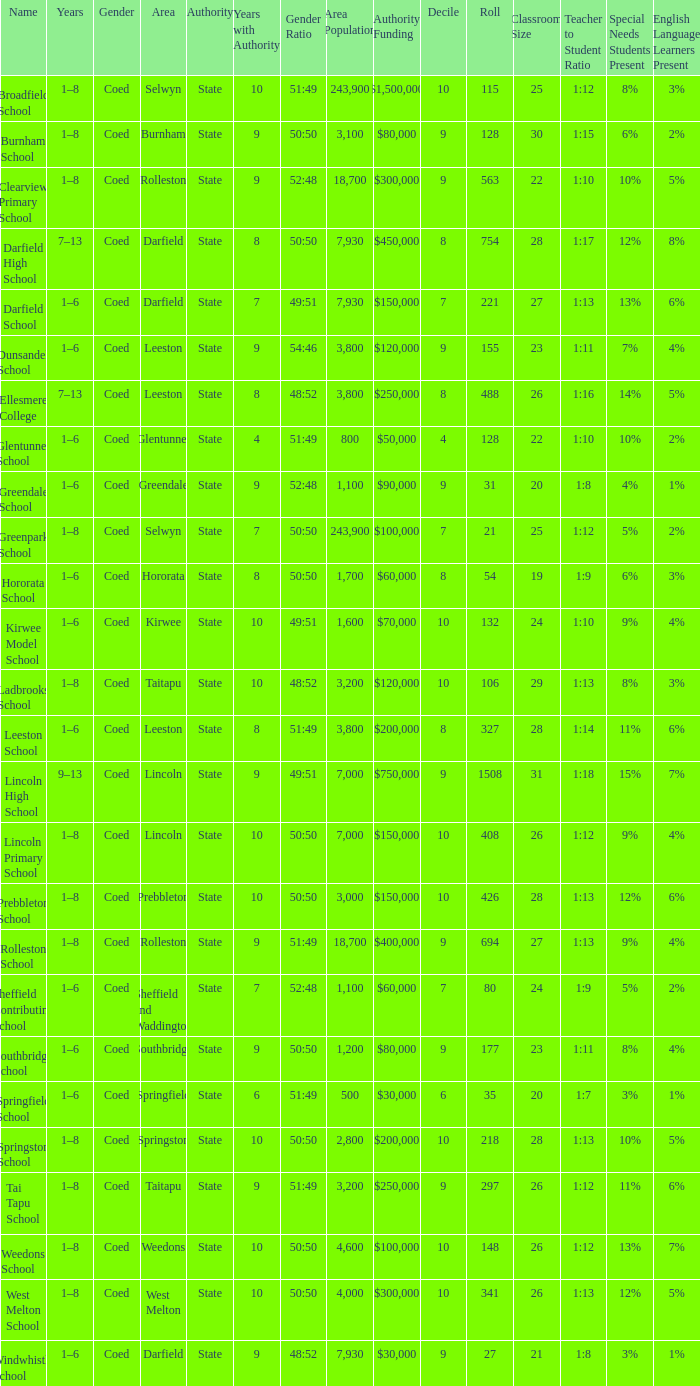What is the name with a Decile less than 10, and a Roll of 297? Tai Tapu School. 